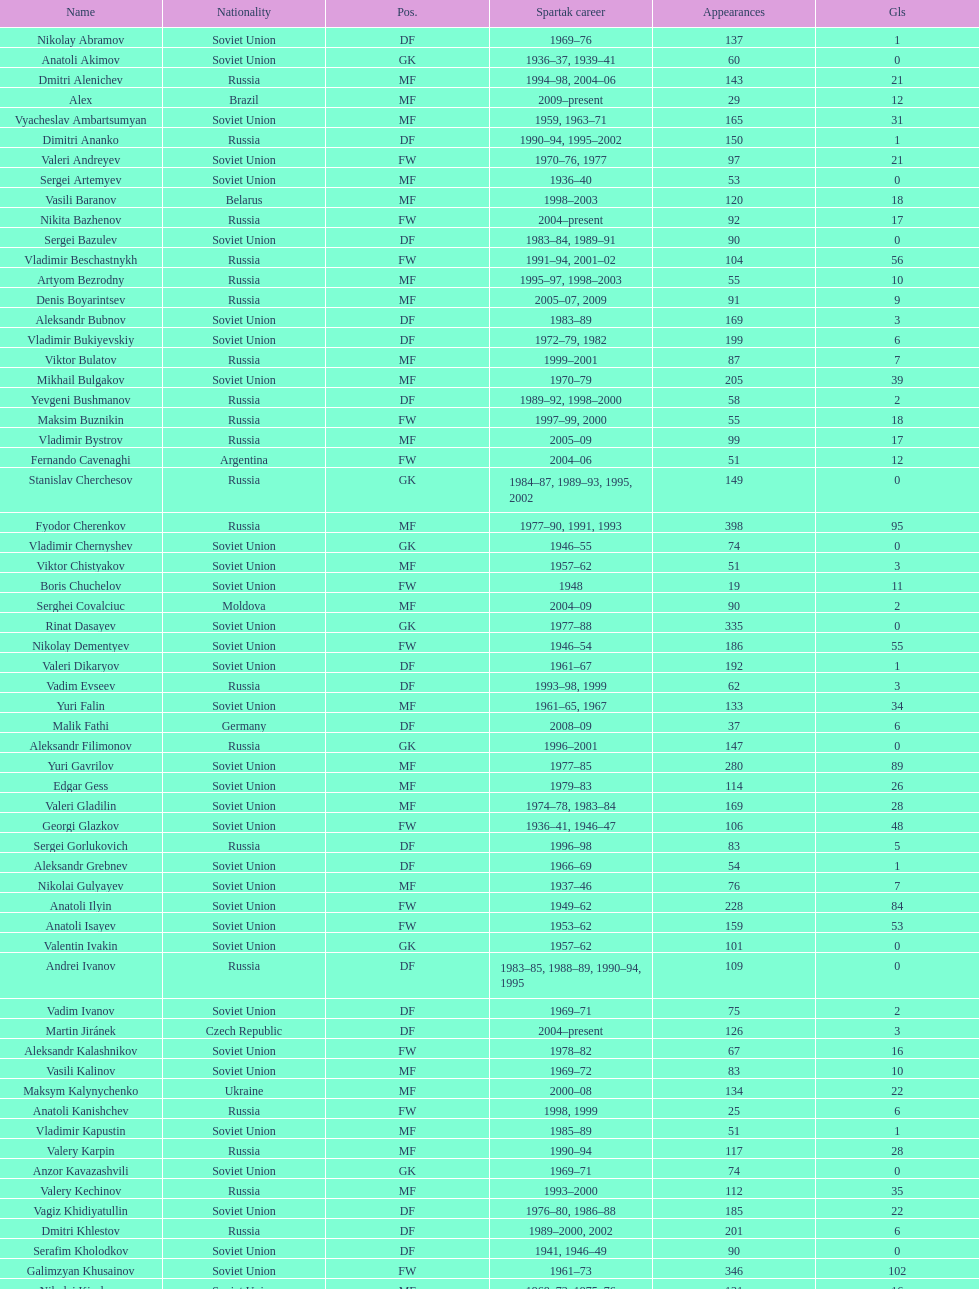Who had the highest number of appearances? Fyodor Cherenkov. 